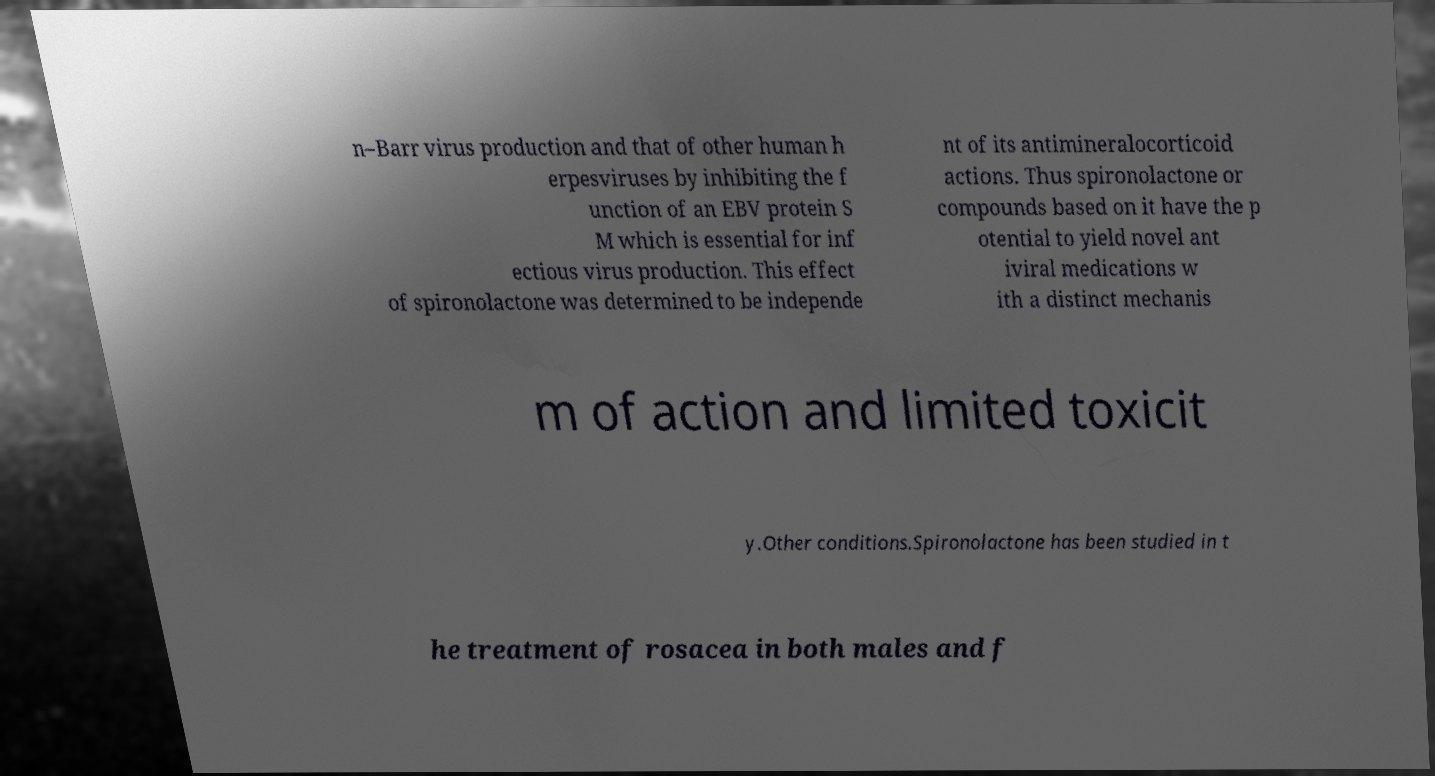Could you assist in decoding the text presented in this image and type it out clearly? n–Barr virus production and that of other human h erpesviruses by inhibiting the f unction of an EBV protein S M which is essential for inf ectious virus production. This effect of spironolactone was determined to be independe nt of its antimineralocorticoid actions. Thus spironolactone or compounds based on it have the p otential to yield novel ant iviral medications w ith a distinct mechanis m of action and limited toxicit y.Other conditions.Spironolactone has been studied in t he treatment of rosacea in both males and f 